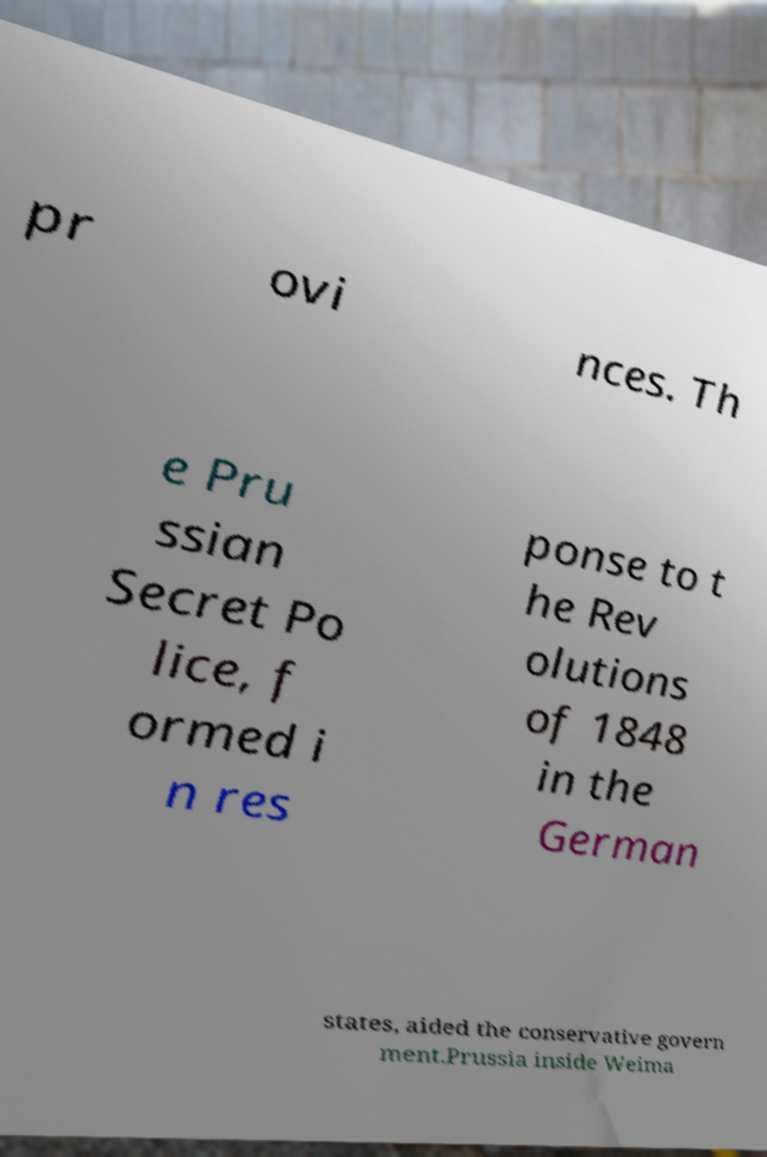What messages or text are displayed in this image? I need them in a readable, typed format. pr ovi nces. Th e Pru ssian Secret Po lice, f ormed i n res ponse to t he Rev olutions of 1848 in the German states, aided the conservative govern ment.Prussia inside Weima 